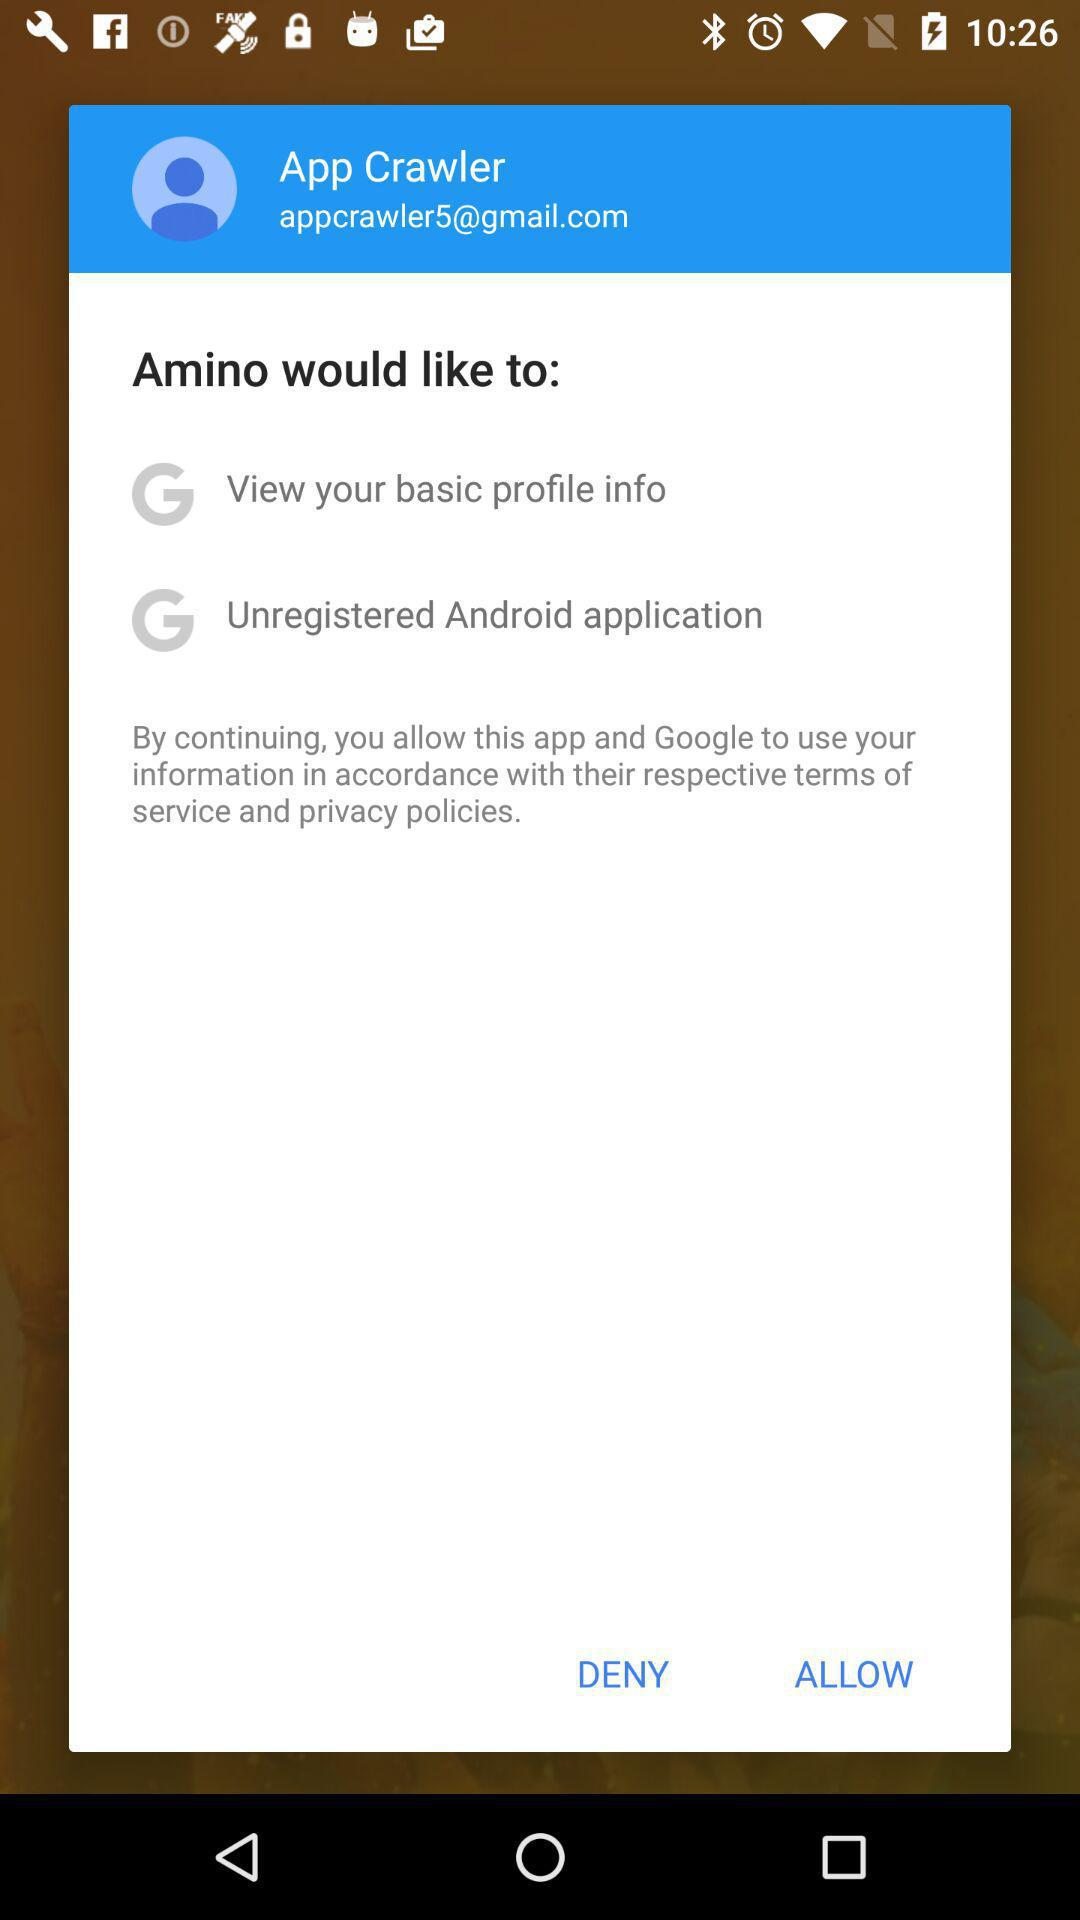What application would like to see a basic profile? The application is "Amino". 